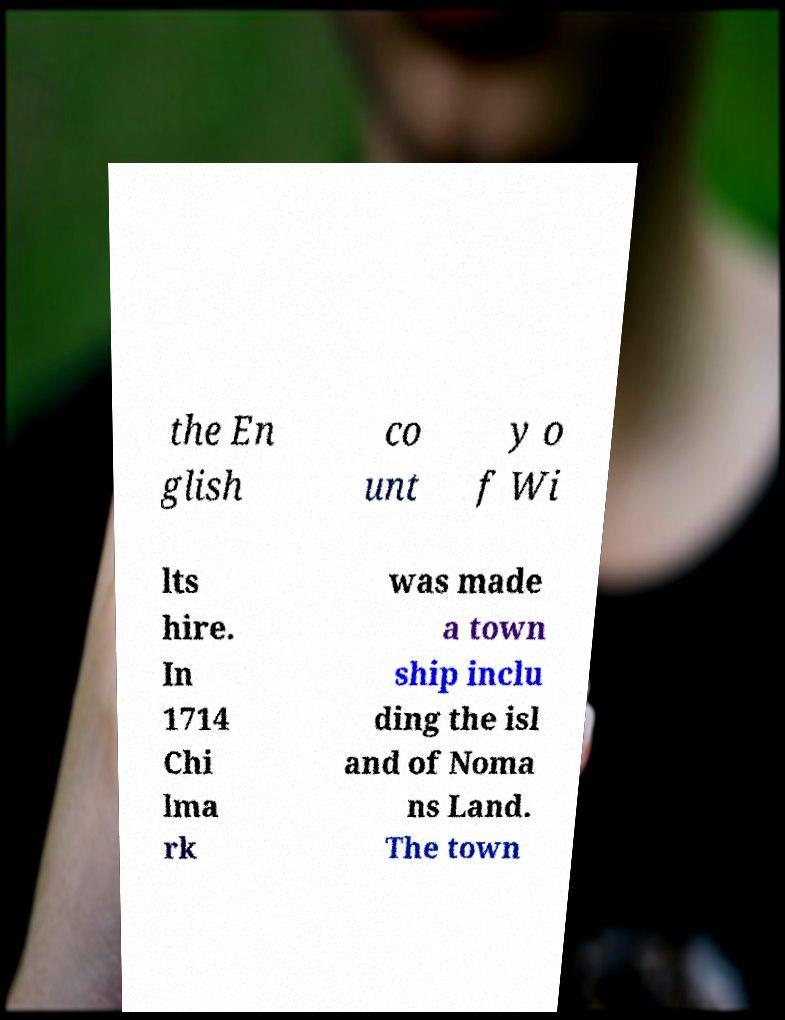Could you extract and type out the text from this image? the En glish co unt y o f Wi lts hire. In 1714 Chi lma rk was made a town ship inclu ding the isl and of Noma ns Land. The town 